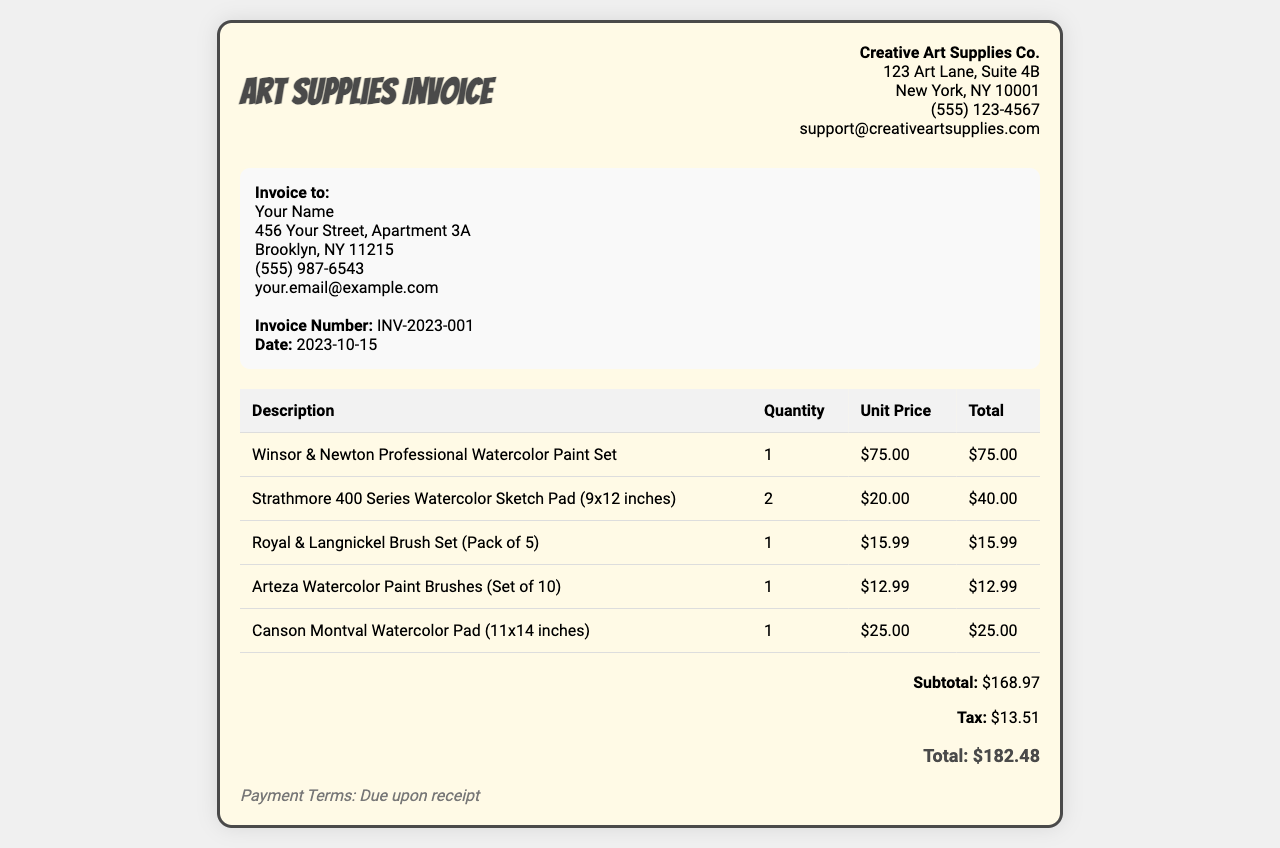What is the total amount due? The total amount due is specified at the end of the invoice in the total section.
Answer: $182.48 Who is the invoice issued to? The invoice is addressed to the recipient's name and address present in the document.
Answer: Your Name What is the date of the invoice? The date can be found in the invoice details section of the document.
Answer: 2023-10-15 How many Strathmore watercolor sketch pads were purchased? The quantity of Strathmore watercolor sketch pads is listed in the itemized table.
Answer: 2 What is the unit price of the Winsor & Newton Professional Watercolor Paint Set? The unit price can be located next to the corresponding item in the invoice table.
Answer: $75.00 What is the subtotal amount before tax? The subtotal amount is provided in the total section of the invoice document.
Answer: $168.97 What is the invoice number? The document specifies an invoice number in the invoice details section.
Answer: INV-2023-001 What is the tax amount calculated? The tax amount is listed in the total section of the invoice.
Answer: $13.51 Which company issued the invoice? The company name is located at the top of the invoice next to the header.
Answer: Creative Art Supplies Co 